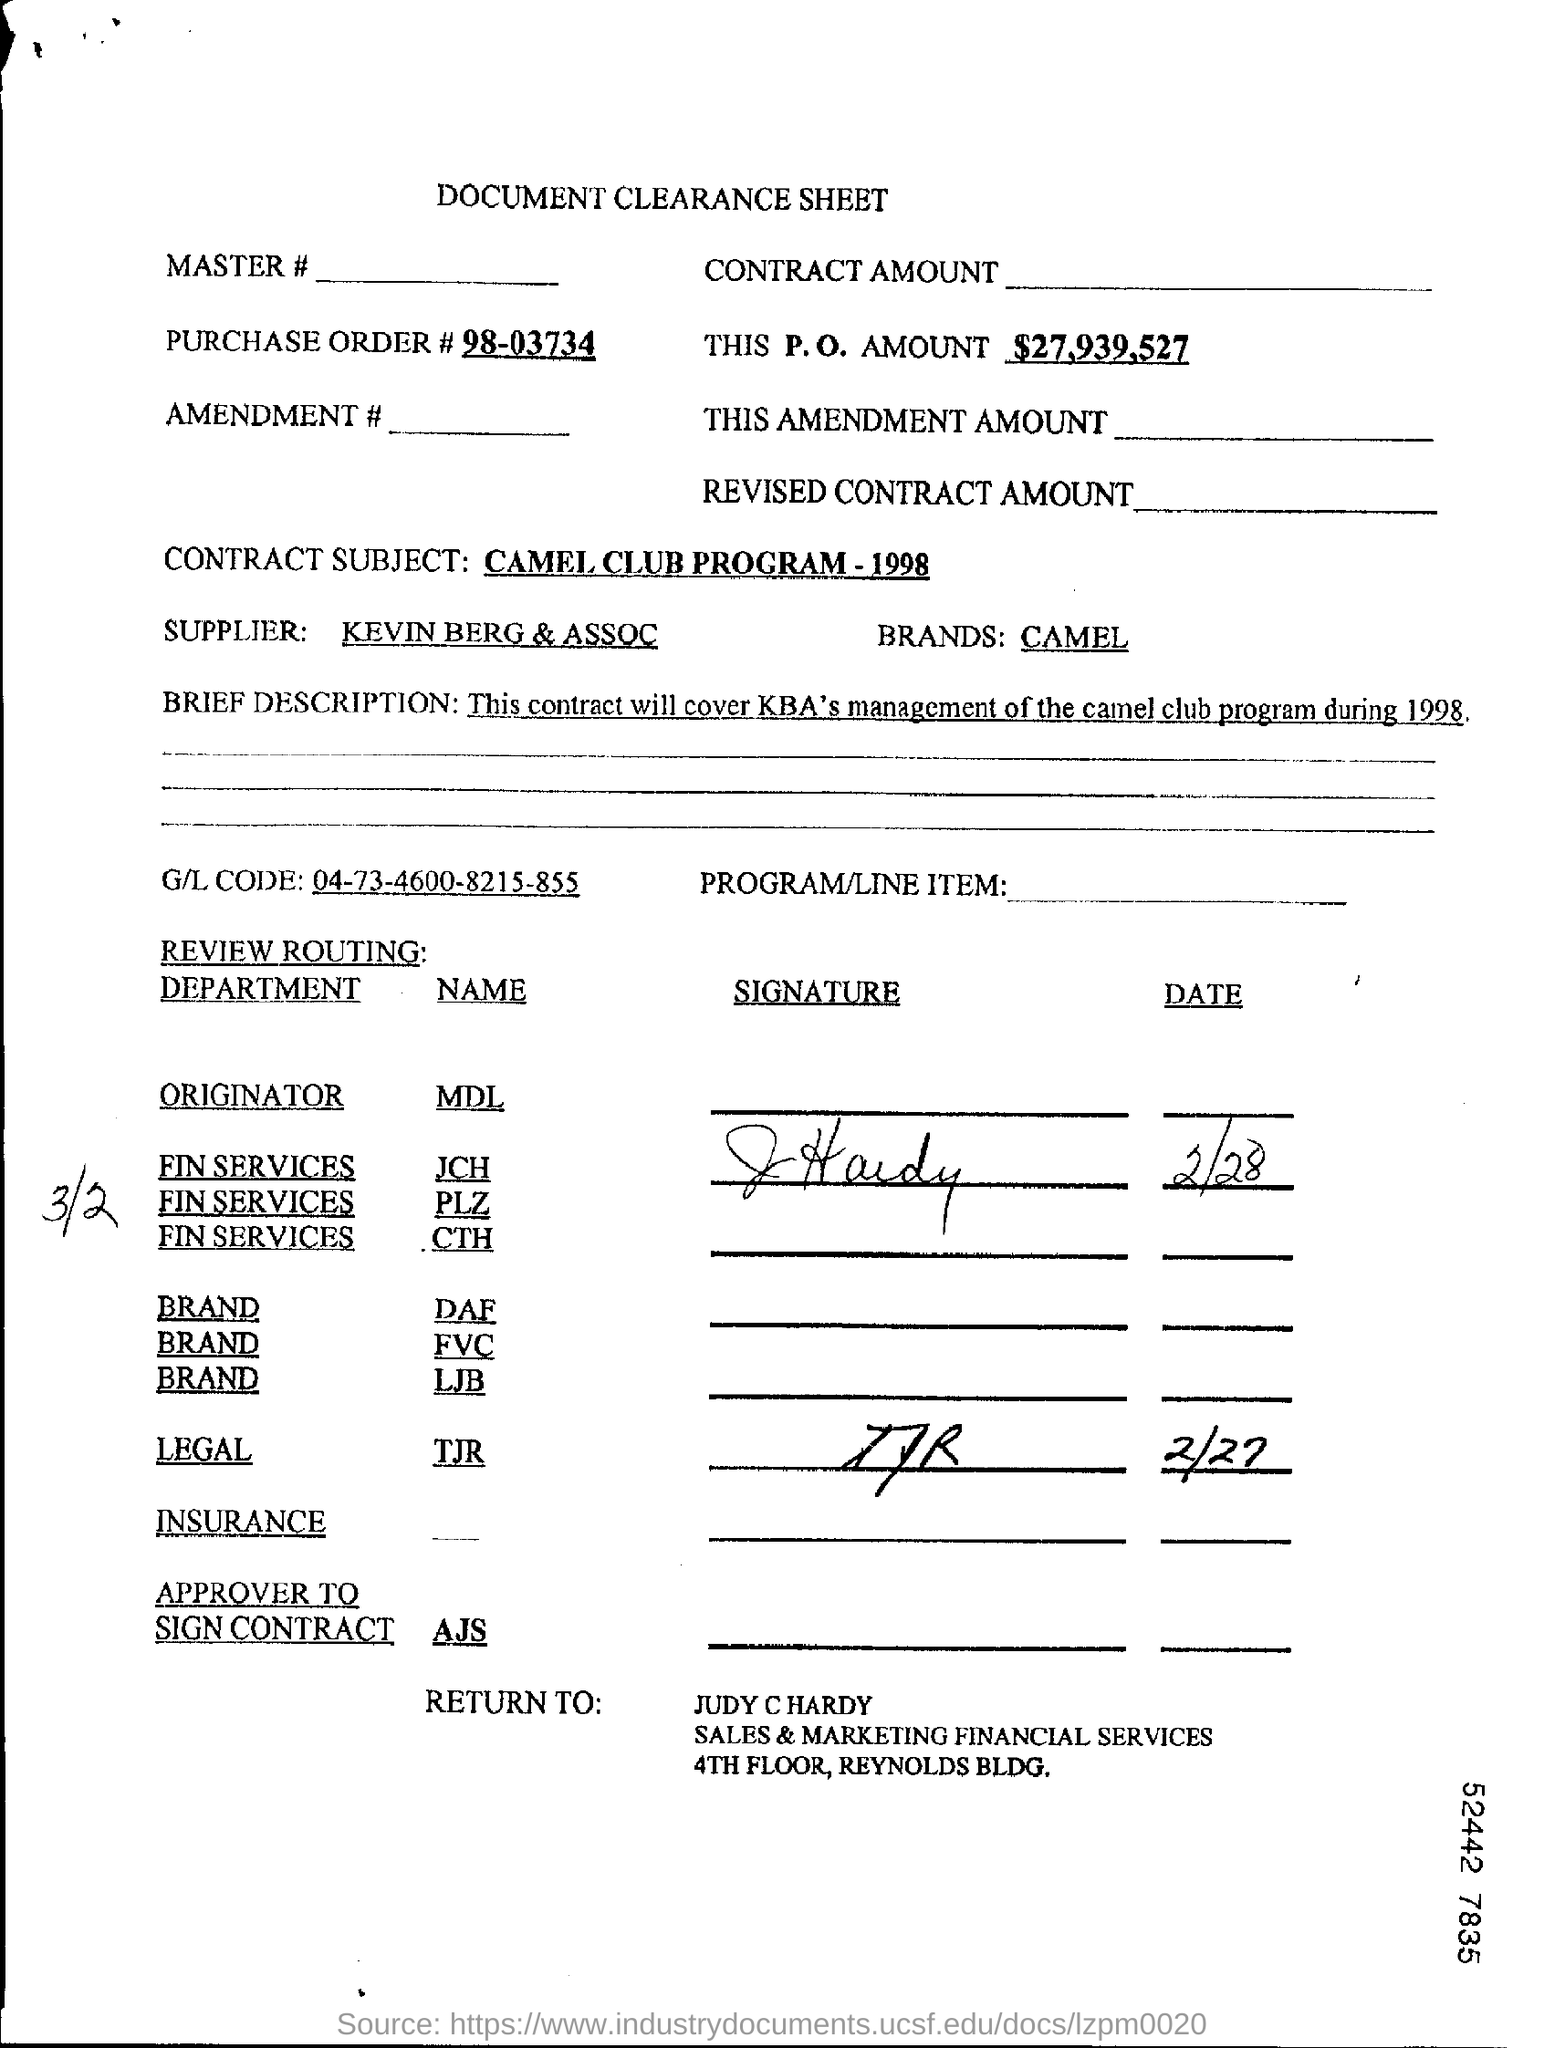Indicate a few pertinent items in this graphic. This is a P.O. amount of $27,939,527.. The contract subject is "CAMEL CLUB PROGRAM - 1998," which refers to a specific program with a specific year of establishment. The purchase order number is 98-03734... The GL account code mentioned is 04-73-4600-8215-855. The form should be returned to JUDY C HARDY. 